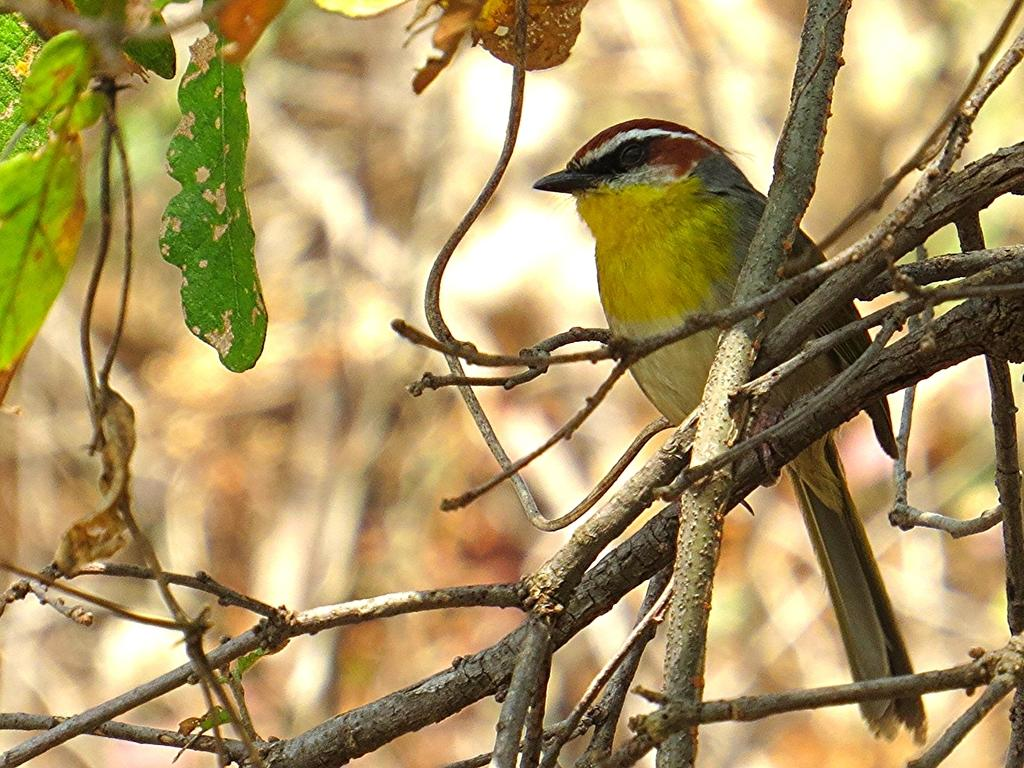What type of animal can be seen in the image? There is a bird in the image. Where is the bird located? The bird is sitting on a stem in the image. What else can be seen in the image besides the bird? There are leaves in the image. Can you describe the background of the image? The background of the image is blurred. What type of substance is the bird using to communicate with its grandmother in the image? There is no substance or grandmother present in the image; it only features a bird sitting on a stem with leaves in the background. 